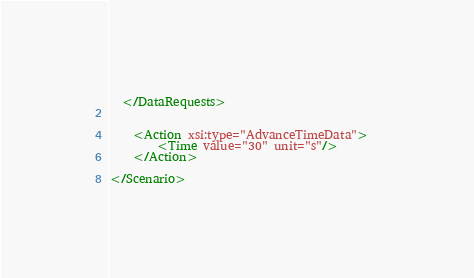Convert code to text. <code><loc_0><loc_0><loc_500><loc_500><_XML_>  </DataRequests>
	
	
	<Action xsi:type="AdvanceTimeData">
        <Time value="30" unit="s"/>       
    </Action>
	
</Scenario></code> 